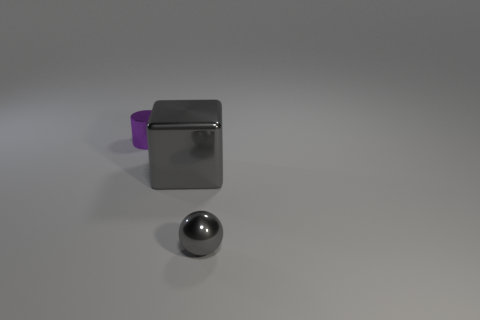Add 1 gray objects. How many objects exist? 4 Subtract all cylinders. How many objects are left? 2 Add 1 purple metal objects. How many purple metal objects are left? 2 Add 2 cyan cylinders. How many cyan cylinders exist? 2 Subtract 0 blue cubes. How many objects are left? 3 Subtract all large yellow rubber cubes. Subtract all gray things. How many objects are left? 1 